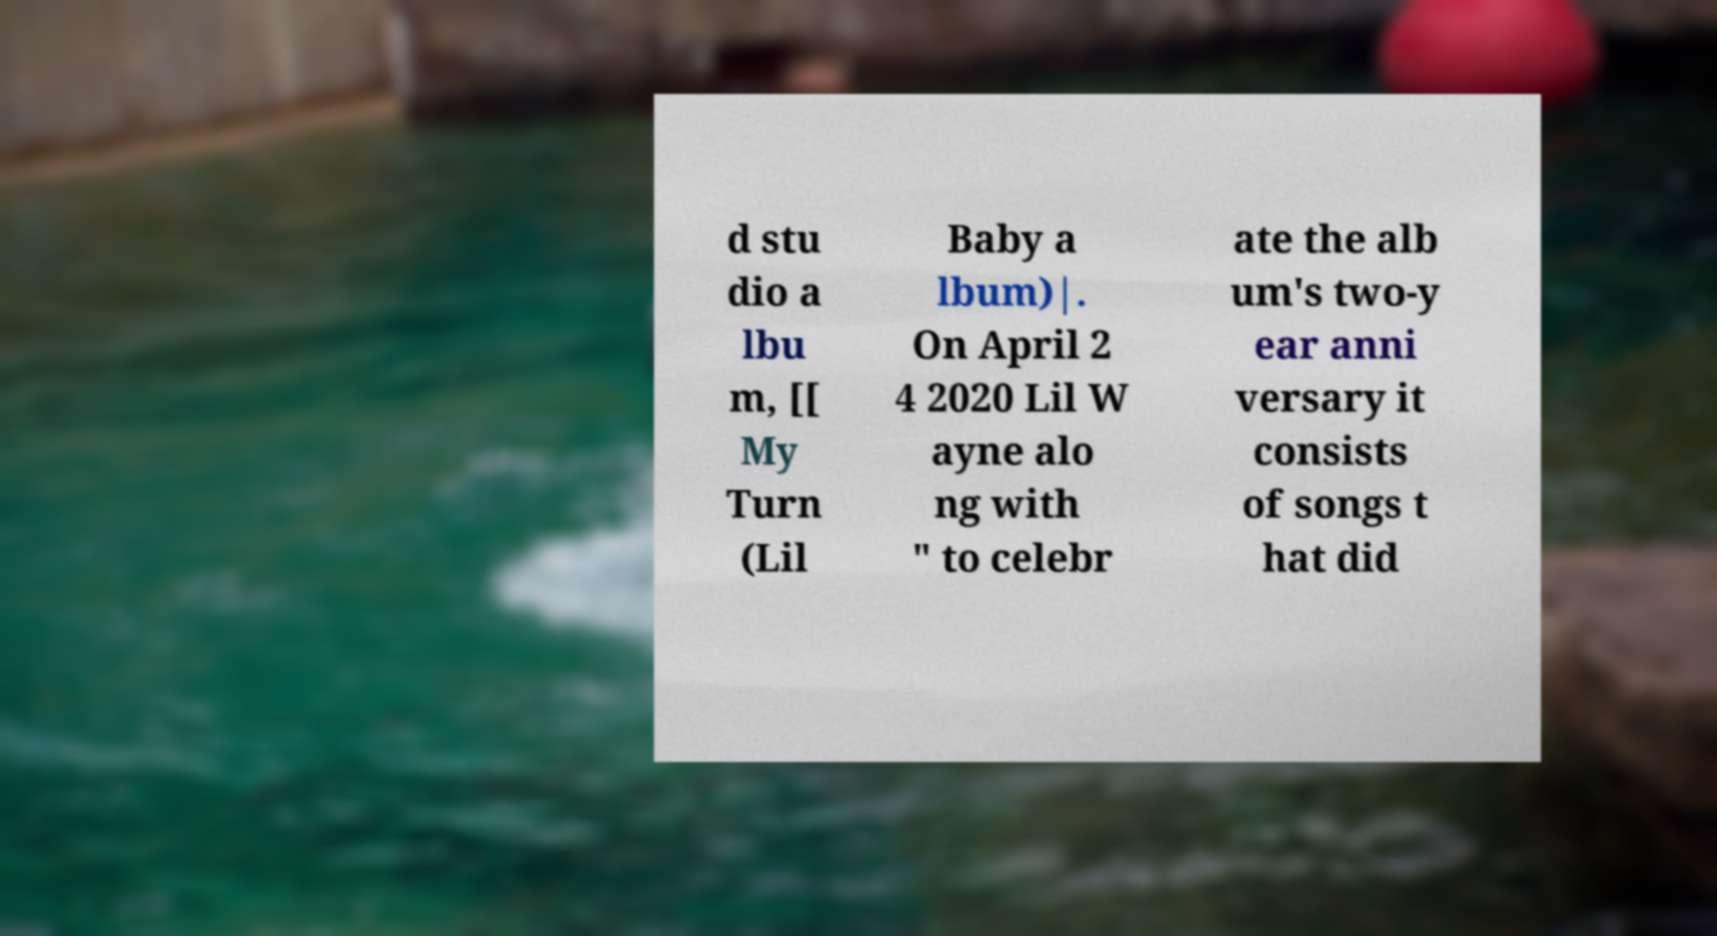Please read and relay the text visible in this image. What does it say? d stu dio a lbu m, [[ My Turn (Lil Baby a lbum)|. On April 2 4 2020 Lil W ayne alo ng with " to celebr ate the alb um's two-y ear anni versary it consists of songs t hat did 